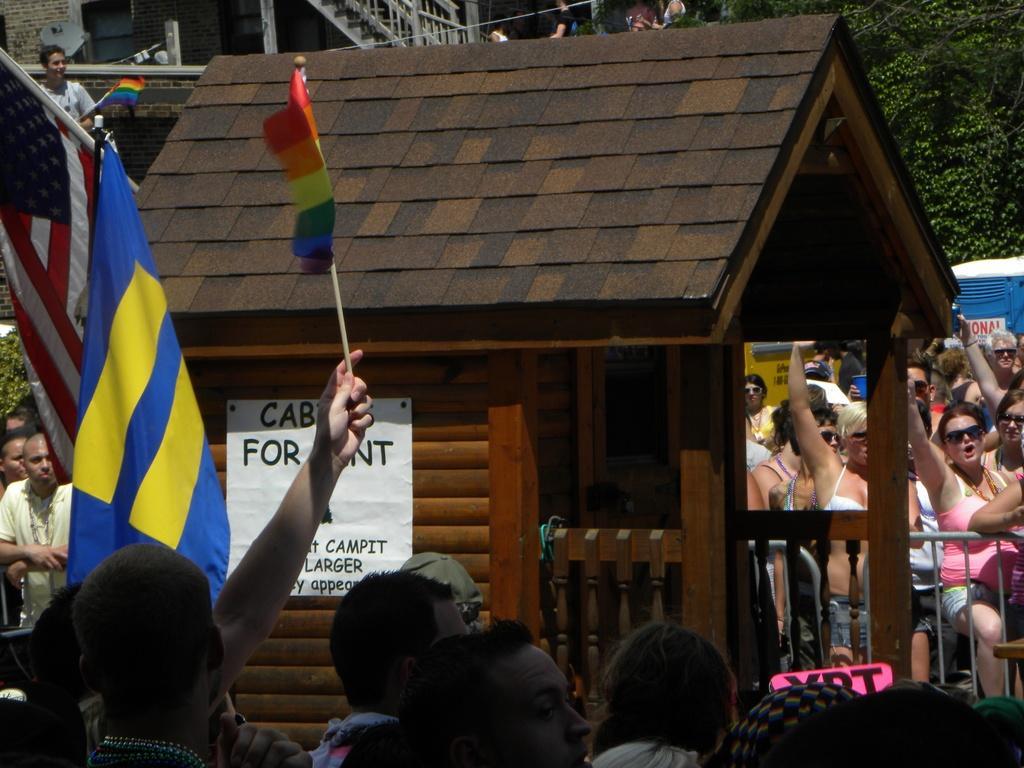Could you give a brief overview of what you see in this image? In this picture we can see group of people and few people holding flags, in the middle of the image we can see a poster on the wall, in the background we can find few trees and a building. 